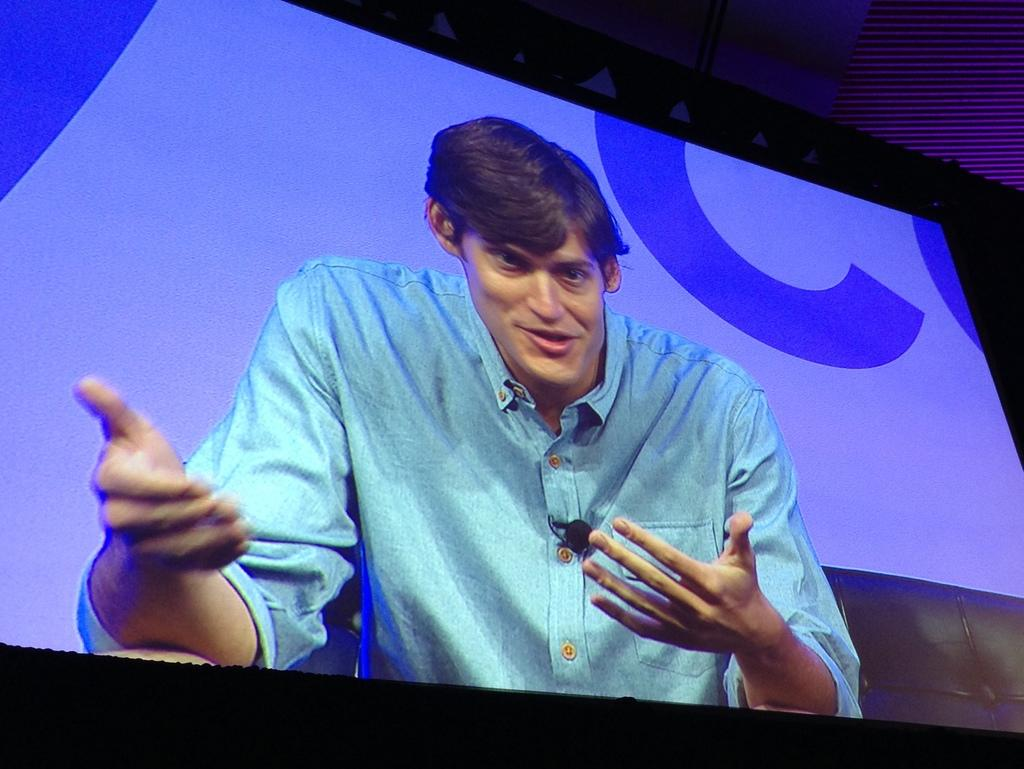What is the main object in the foreground of the image? There is a screen in the foreground of the image. What is the man in the image doing? The man is sitting on a couch in front of the screen. How would you describe the lighting in the image? The top and bottom of the image are dark. What type of honey is the man eating for breakfast in the image? There is no mention of honey or breakfast in the image, so it cannot be determined from the image. 